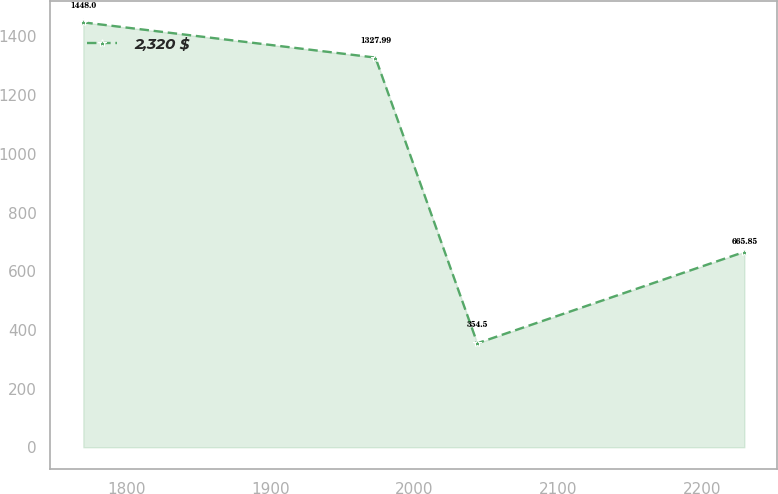Convert chart. <chart><loc_0><loc_0><loc_500><loc_500><line_chart><ecel><fcel>2,320 $<nl><fcel>1769.89<fcel>1448<nl><fcel>1972.91<fcel>1327.99<nl><fcel>2043.73<fcel>354.5<nl><fcel>2229.36<fcel>665.85<nl></chart> 